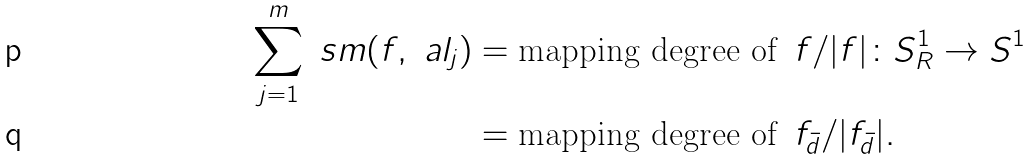<formula> <loc_0><loc_0><loc_500><loc_500>\sum _ { j = 1 } ^ { m } \ s m ( f , \ a l _ { j } ) & = \text {mapping degree of } \, f / | f | \colon S _ { R } ^ { 1 } \to S ^ { 1 } \\ & = \text {mapping degree of } \, f _ { \bar { d } } / | f _ { \bar { d } } | .</formula> 